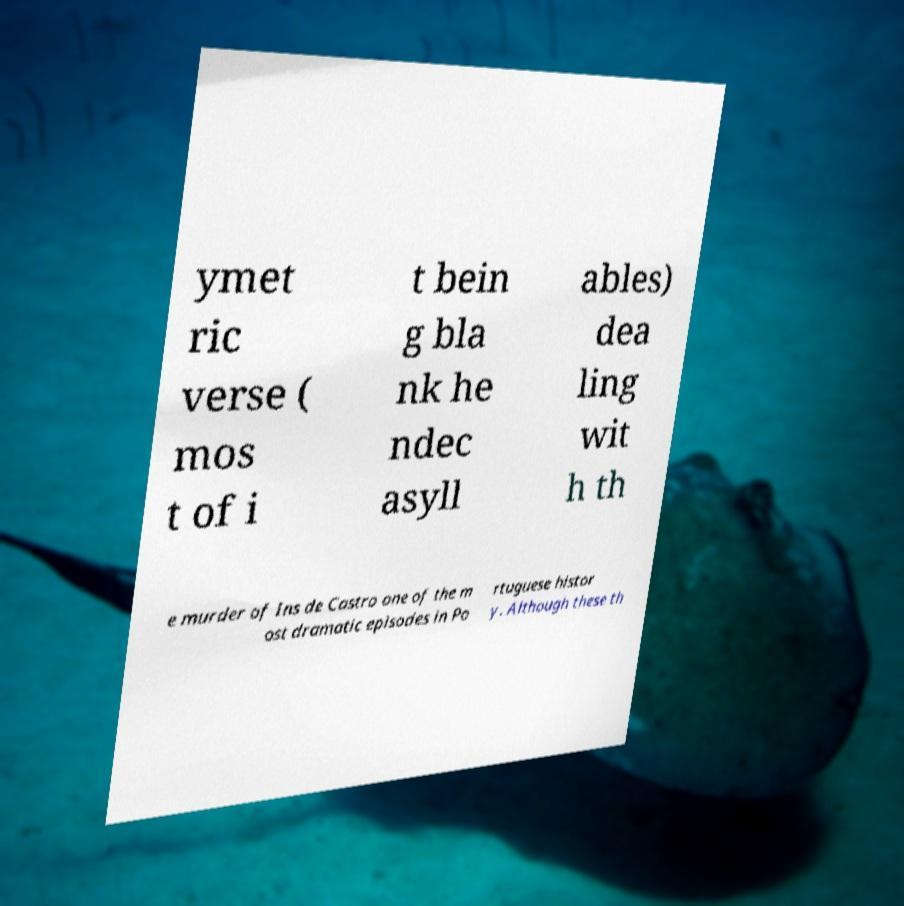I need the written content from this picture converted into text. Can you do that? ymet ric verse ( mos t of i t bein g bla nk he ndec asyll ables) dea ling wit h th e murder of Ins de Castro one of the m ost dramatic episodes in Po rtuguese histor y. Although these th 